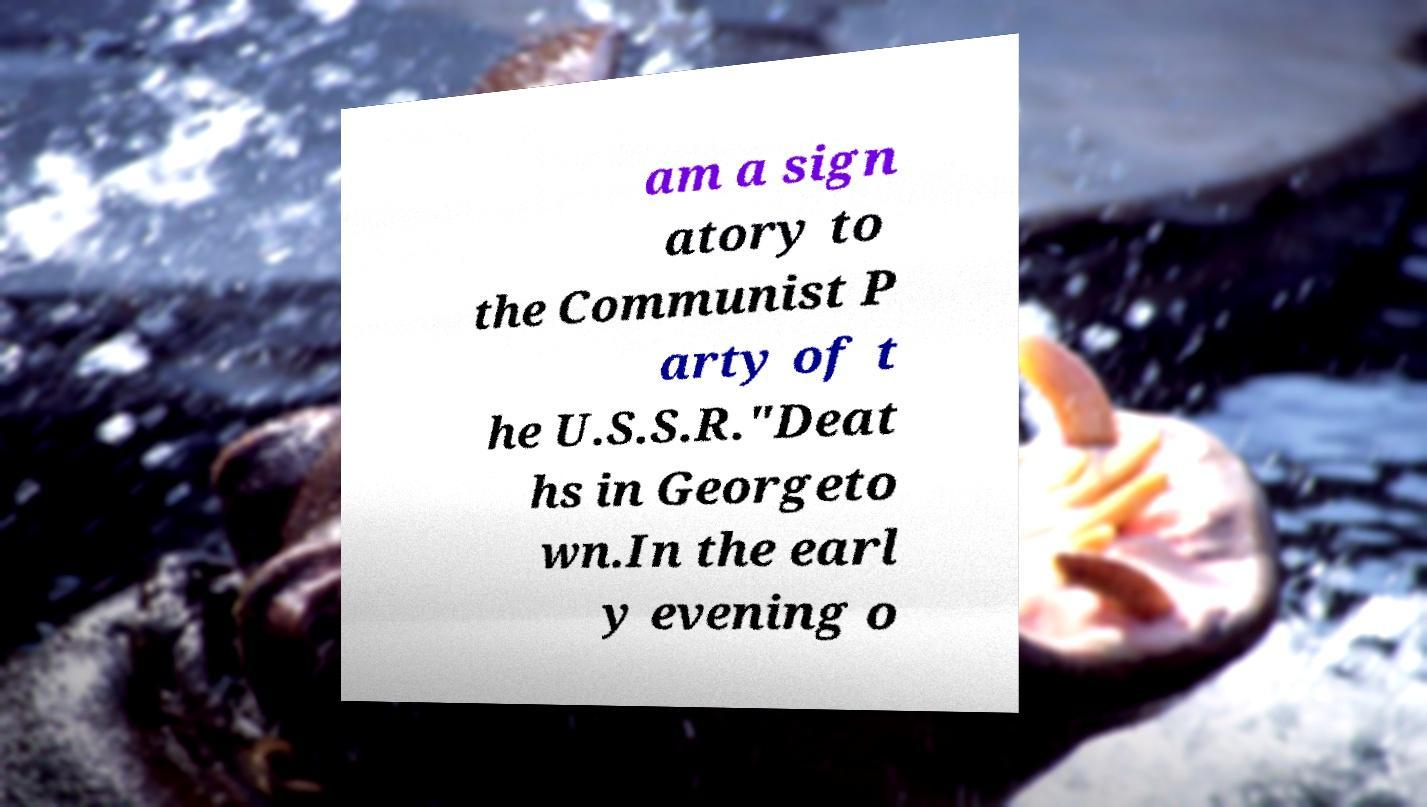Can you read and provide the text displayed in the image?This photo seems to have some interesting text. Can you extract and type it out for me? am a sign atory to the Communist P arty of t he U.S.S.R."Deat hs in Georgeto wn.In the earl y evening o 